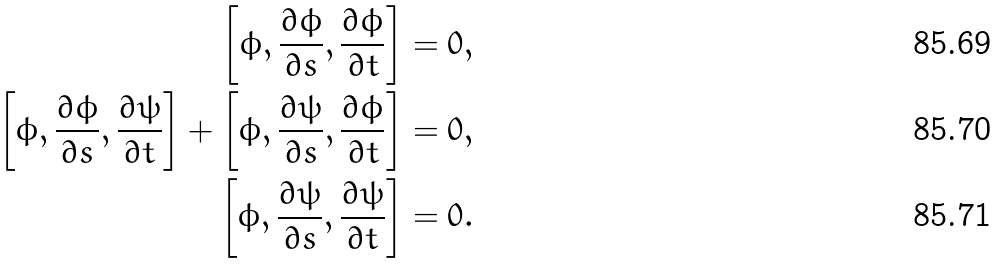<formula> <loc_0><loc_0><loc_500><loc_500>\left [ \phi , \frac { \partial \phi } { \partial s } , \frac { \partial \phi } { \partial t } \right ] & = 0 , \\ \left [ \phi , \frac { \partial \phi } { \partial s } , \frac { \partial \psi } { \partial t } \right ] + \left [ \phi , \frac { \partial \psi } { \partial s } , \frac { \partial \phi } { \partial t } \right ] & = 0 , \\ \left [ \phi , \frac { \partial \psi } { \partial s } , \frac { \partial \psi } { \partial t } \right ] & = 0 .</formula> 